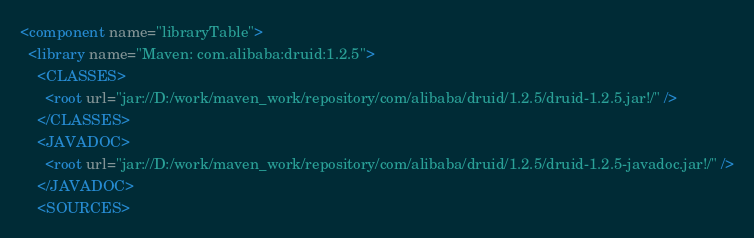Convert code to text. <code><loc_0><loc_0><loc_500><loc_500><_XML_><component name="libraryTable">
  <library name="Maven: com.alibaba:druid:1.2.5">
    <CLASSES>
      <root url="jar://D:/work/maven_work/repository/com/alibaba/druid/1.2.5/druid-1.2.5.jar!/" />
    </CLASSES>
    <JAVADOC>
      <root url="jar://D:/work/maven_work/repository/com/alibaba/druid/1.2.5/druid-1.2.5-javadoc.jar!/" />
    </JAVADOC>
    <SOURCES></code> 